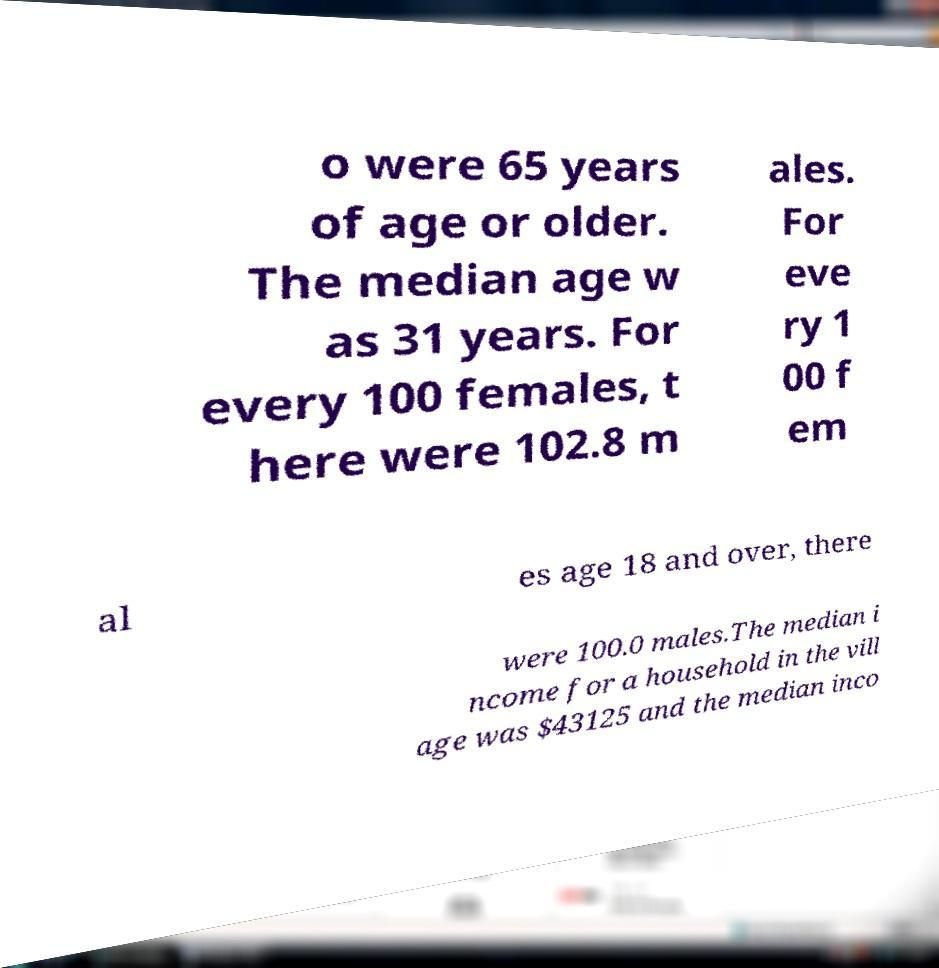Could you assist in decoding the text presented in this image and type it out clearly? o were 65 years of age or older. The median age w as 31 years. For every 100 females, t here were 102.8 m ales. For eve ry 1 00 f em al es age 18 and over, there were 100.0 males.The median i ncome for a household in the vill age was $43125 and the median inco 